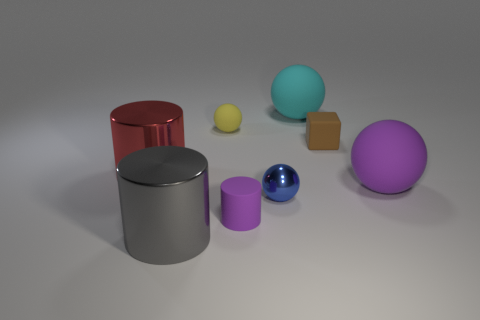Add 2 big green shiny cylinders. How many objects exist? 10 Subtract all blocks. How many objects are left? 7 Subtract all big brown blocks. Subtract all red cylinders. How many objects are left? 7 Add 8 purple rubber balls. How many purple rubber balls are left? 9 Add 3 yellow matte spheres. How many yellow matte spheres exist? 4 Subtract 0 purple blocks. How many objects are left? 8 